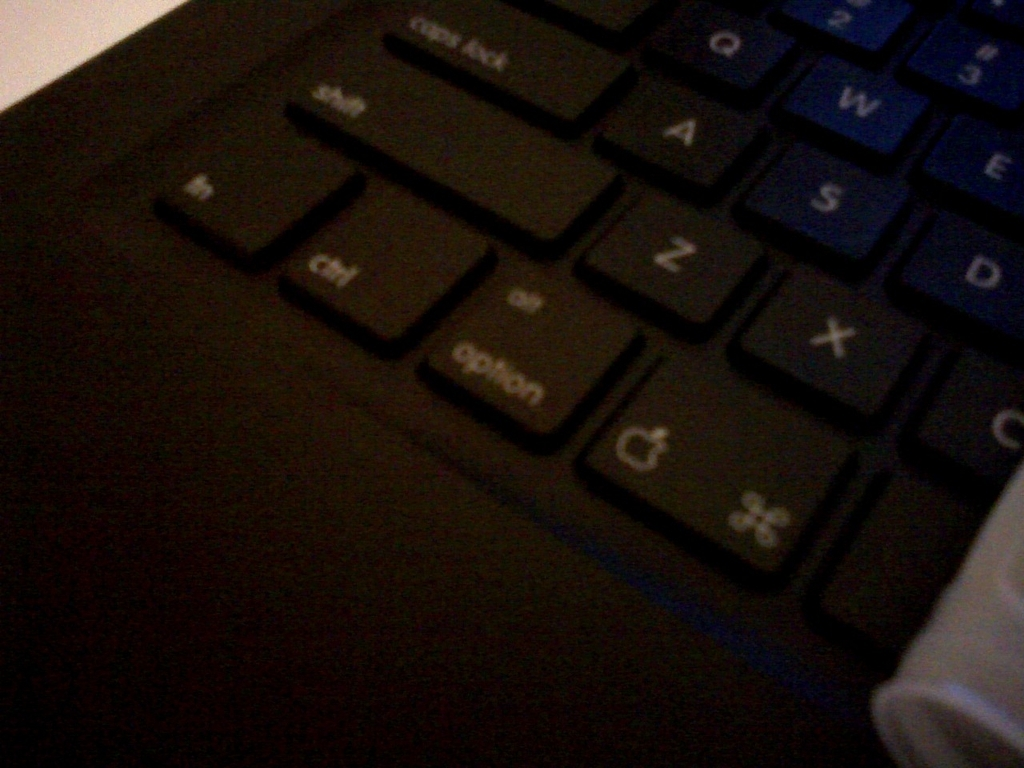What type of device is shown in the image? The image displays a keyboard, which appears to be part of a laptop or a standalone peripheral for a desktop computer. 